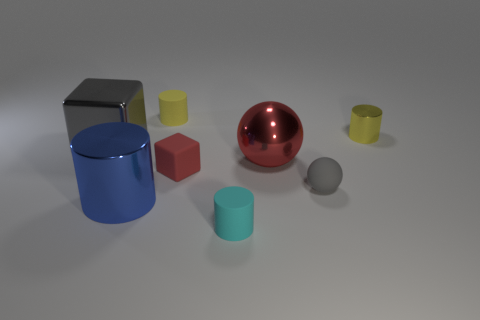Subtract all blue cylinders. Subtract all yellow cubes. How many cylinders are left? 3 Add 2 big blue objects. How many objects exist? 10 Subtract all cubes. How many objects are left? 6 Add 2 metallic cubes. How many metallic cubes exist? 3 Subtract 1 blue cylinders. How many objects are left? 7 Subtract all large blue shiny cylinders. Subtract all big red things. How many objects are left? 6 Add 2 big things. How many big things are left? 5 